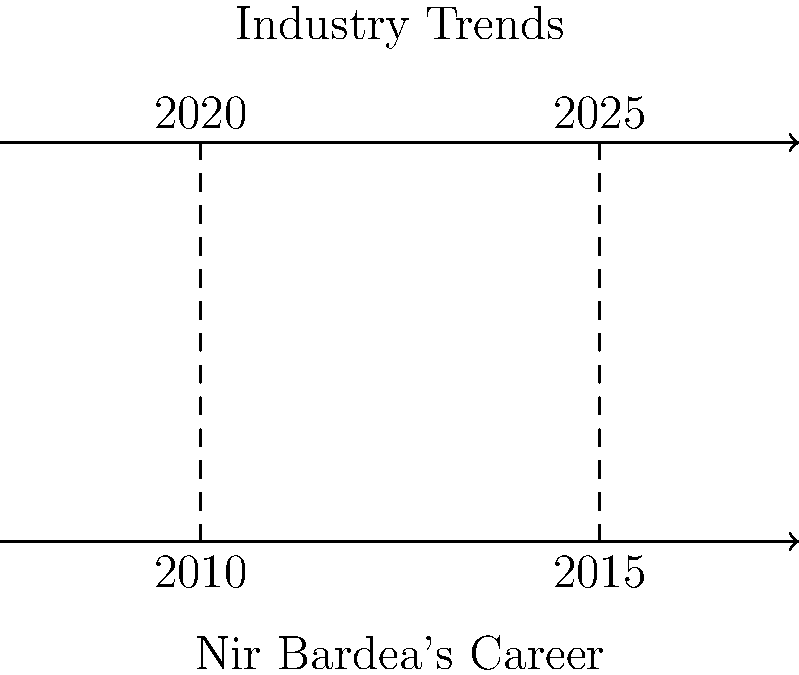In the diagram, Nir Bardea's career trajectory and industry trends are represented by two parallel lines. Given that the vertical distance between these lines remains constant, what geometric property is demonstrated, and how does it relate to Nir Bardea's career development? To answer this question, let's analyze the diagram and its implications step-by-step:

1. The diagram shows two parallel lines: one representing Nir Bardea's career trajectory and the other representing industry trends.

2. The lines are marked with years (2010, 2015, 2020, 2025) to indicate progression over time.

3. The key geometric property demonstrated here is congruence. Specifically, we're looking at the congruence of corresponding line segments between the parallel lines.

4. In geometry, when two lines are parallel, any line segment perpendicular to both lines (called a transversal) creates congruent segments between the parallel lines. This is known as the "parallel line theorem" or "alternate interior angles theorem."

5. In this context, the vertical dashed lines represent these transversals, and the segments they create between the parallel lines are congruent.

6. Mathematically, if we denote the distance between the parallel lines as $d$, we can say that for any two points $P_1$ and $P_2$ on Nir Bardea's career line, and their corresponding points $Q_1$ and $Q_2$ on the industry trends line:

   $$\overline{P_1Q_1} \cong \overline{P_2Q_2}$$

   where $\cong$ denotes congruence.

7. In terms of Nir Bardea's career development, this congruence suggests that his career trajectory consistently aligns with industry trends over time. The constant distance between the lines implies that he maintains a steady relationship with industry developments, neither falling behind nor surging far ahead.

8. This geometric representation indicates that Nir Bardea's career growth is in sync with industry evolution, showing adaptability and relevance in his field over the years.
Answer: Congruence of corresponding segments, indicating consistent alignment with industry trends 